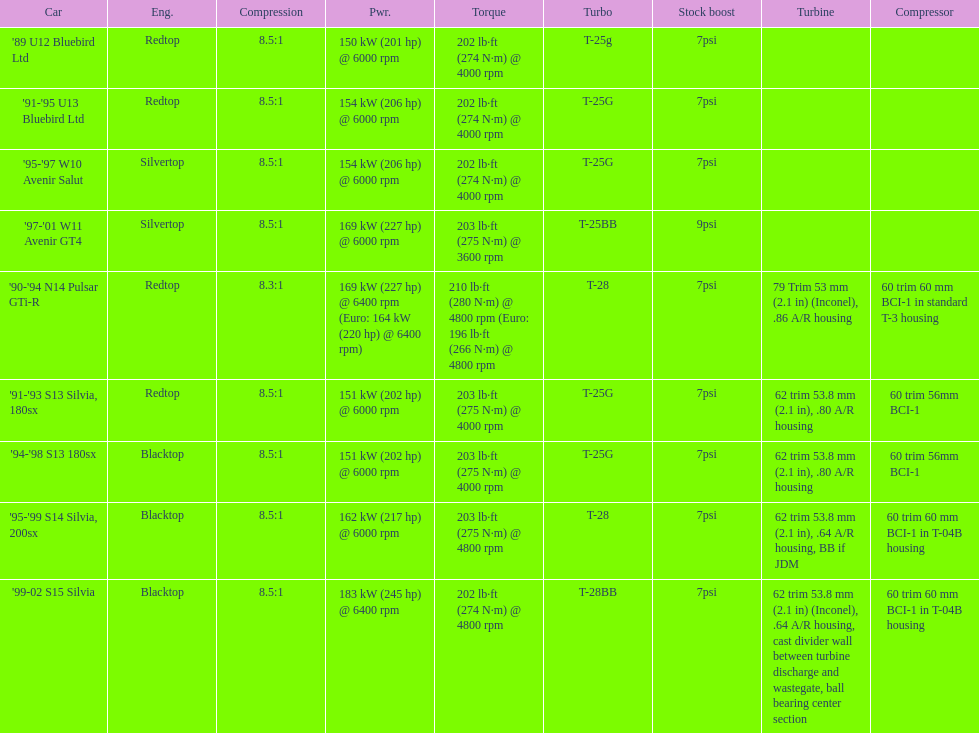Which engine has the smallest compression rate? '90-'94 N14 Pulsar GTi-R. 